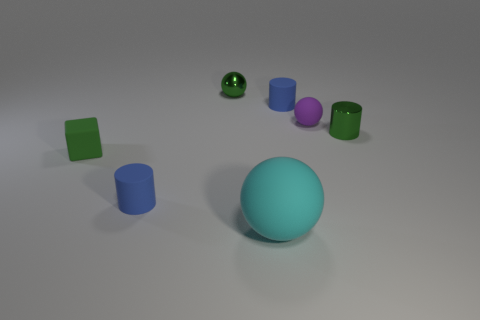What number of other tiny rubber things have the same shape as the small green matte thing?
Your response must be concise. 0. What is the size of the cyan object that is the same material as the cube?
Give a very brief answer. Large. There is a tiny sphere to the left of the cyan thing that is in front of the green rubber block; what is its color?
Offer a very short reply. Green. There is a cyan matte thing; does it have the same shape as the tiny blue thing that is behind the green rubber cube?
Your answer should be very brief. No. What number of green shiny balls are the same size as the block?
Provide a short and direct response. 1. There is a cyan thing that is the same shape as the purple object; what material is it?
Provide a succinct answer. Rubber. Do the small cylinder behind the purple object and the metallic object on the left side of the purple matte thing have the same color?
Your answer should be very brief. No. There is a small green object on the right side of the big cyan sphere; what shape is it?
Ensure brevity in your answer.  Cylinder. What color is the large rubber ball?
Provide a succinct answer. Cyan. There is a large thing that is the same material as the tiny green cube; what is its shape?
Keep it short and to the point. Sphere. 